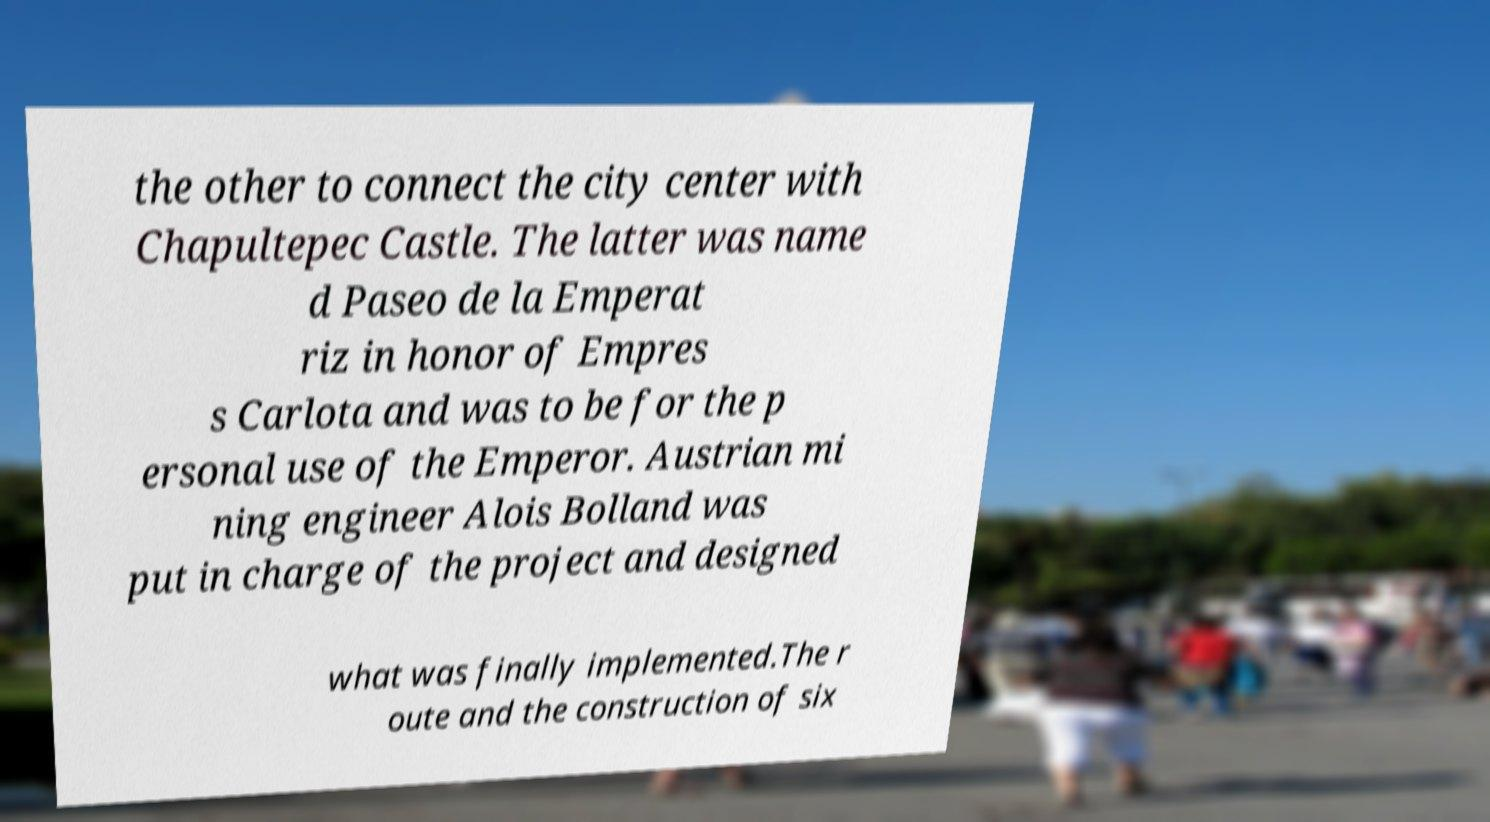Could you assist in decoding the text presented in this image and type it out clearly? the other to connect the city center with Chapultepec Castle. The latter was name d Paseo de la Emperat riz in honor of Empres s Carlota and was to be for the p ersonal use of the Emperor. Austrian mi ning engineer Alois Bolland was put in charge of the project and designed what was finally implemented.The r oute and the construction of six 